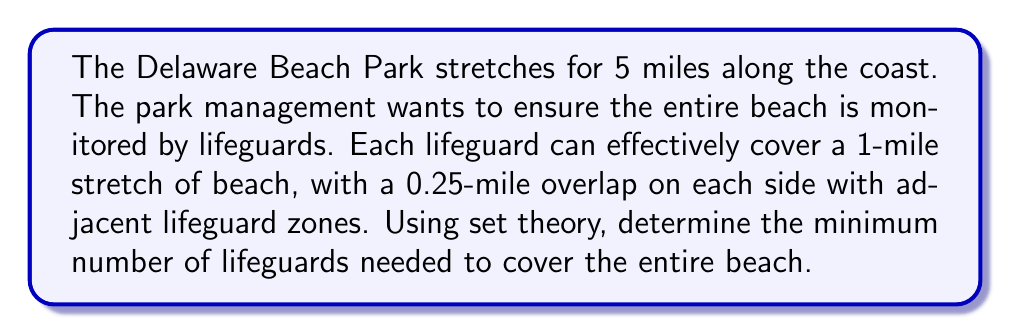Help me with this question. Let's approach this problem using set theory:

1) First, we need to determine the effective coverage of each lifeguard without overlap:
   Effective coverage = Total coverage - Overlap
   $1 - (0.25 + 0.25) = 0.5$ miles

2) Now, we can treat the beach as a set $B$ of length 5 miles, and each lifeguard's coverage as a subset $L_i$ of length 0.5 miles.

3) We need to find the minimum number of subsets $L_i$ that can cover the entire set $B$.

4) Mathematically, we're looking for the smallest $n$ such that:

   $$B \subseteq \bigcup_{i=1}^n L_i$$

5) Since each $L_i$ covers 0.5 miles effectively, we can calculate $n$ as:

   $$n = \left\lceil\frac{\text{Total beach length}}{\text{Effective coverage per lifeguard}}\right\rceil$$

6) Plugging in our values:

   $$n = \left\lceil\frac{5}{0.5}\right\rceil = \left\lceil10\right\rceil = 10$$

7) Therefore, a minimum of 10 lifeguards are needed to cover the entire beach.

8) We can verify this:
   - 10 lifeguards * 0.5 miles effective coverage each = 5 miles total coverage
   - This exactly matches the length of the beach

Note: The ceiling function $\lceil \cdot \rceil$ is used because we need a whole number of lifeguards, and we must round up to ensure complete coverage.
Answer: The minimum number of lifeguards needed is 10. 